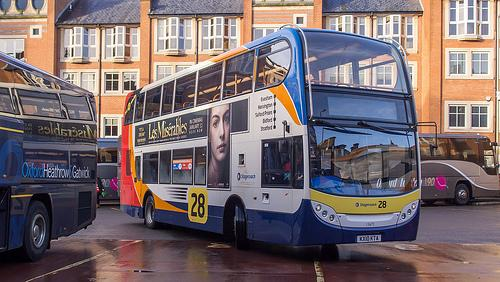Provide a list of distinct features on the bus. Large windshield, upper deck, number 28 written in black with a yellow background, red and yellow stripe, windshield wipers, and an advertisement on its side. How many glass windows are visible on the building?  Twelve glass windows are visible on the building. Identify the objects present in the image which are related to transportation. A double level bus, a parked bus, a large blue red and white bus, the bus turning on the street, a grey windowless car parked in the lot, and a car parked next to the bus. Identify what the building and the buses might be used for. The building could be a residential or commercial space with glass windows, while the buses are used for public transportation with one being a double level bus. What can you infer about the location where the image was taken? The image was taken in a wet parking lot with two buses and a building with shingled roof and several glass windows. How are the buses interacting with the parking lot and the surrounding environment? A double level bus and a parked bus are both occupying space in the wet parking lot, with the double level bus appearing to turn onto the street. What kind of sentiment does the wet parking lot with two buses evoke?  The wet parking lot with two buses parked can evoke a sense of calm, gloom, or tranquility depending on the viewer's perspective. Mention the types of windows present in the image and their locations. A large window on a bus, glass windows on the building, and grey windowless car parked in the lot. What kind of vehicle is present in the center of the image and has an upper deck? double level bus Is there any diagram represented in the image? No Do you see the pink flowers growing near the red building? No, it's not mentioned in the image. Which object is located between the white line on pavement and the parked bus, and is round in shape? tyre What number is written on the bus in black with a yellow back? 28 What is the prominent color of the building present in the image with several windows? red Describe any distinctive feature of the bus in terms of its physical appearance. The bus has a red and yellow stripe on it. Is there a car parked in the image? If so, describe its appearance. Yes, there is a grey windowless car parked in the lot. Which of the following best describes the building's roofing material: shingles, slate, wood, or metal? shingles Is there a windshield wiper on the bus? Choose: Yes or No. Yes What do you see on the side of the bus that could be an advertisement? a picture Which object is supposed to have a large windshield but is not a means of transportation? None Based on the objects present, what is a possible location for the scene? A bus parking lot near a red building. Narrate a short story based on the objects in the image as the main characters. The double level bus was turning onto the street after picking up passengers from the bus stop nearby. The number 28 bus, nicknamed "Betty" by its regular riders, was known for its vibrant red and yellow stripe on its side. As it made its way through the wet parking lot, it passed a grey windowless car that appeared to have been in the lot for quite some time. The nearby red building with several windows stood quietly, watching the vehicles pass by. Identify the object located at the top left corner of the image. a red building with several windows Based on the image's objects, what current activity might be happening at the location? Buses are being parked or getting ready to leave. List all objects in the image that can be described as having glass windows. bus, red building, grey car Describe what the front of the bus has in terms of text and color. the bus number 28 in black What emotions can be inferred from the objects in the image? There are no discernible emotions, as objects do not express emotions. Give an example of an event that might happen at the location shown in the image. Two buses and a car driving through the wet parking lot after a rain shower. Count the number of mirrors present in the image. 5 